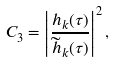Convert formula to latex. <formula><loc_0><loc_0><loc_500><loc_500>C _ { 3 } = \left | \frac { h _ { k } ( \tau ) } { \widetilde { h } _ { k } ( \tau ) } \right | ^ { 2 } ,</formula> 